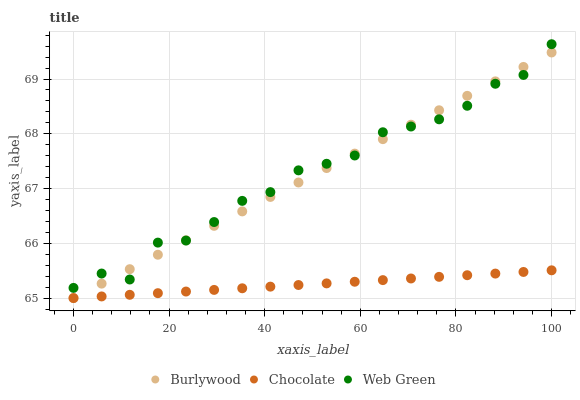Does Chocolate have the minimum area under the curve?
Answer yes or no. Yes. Does Web Green have the maximum area under the curve?
Answer yes or no. Yes. Does Web Green have the minimum area under the curve?
Answer yes or no. No. Does Chocolate have the maximum area under the curve?
Answer yes or no. No. Is Chocolate the smoothest?
Answer yes or no. Yes. Is Web Green the roughest?
Answer yes or no. Yes. Is Web Green the smoothest?
Answer yes or no. No. Is Chocolate the roughest?
Answer yes or no. No. Does Burlywood have the lowest value?
Answer yes or no. Yes. Does Web Green have the lowest value?
Answer yes or no. No. Does Web Green have the highest value?
Answer yes or no. Yes. Does Chocolate have the highest value?
Answer yes or no. No. Is Chocolate less than Web Green?
Answer yes or no. Yes. Is Web Green greater than Chocolate?
Answer yes or no. Yes. Does Web Green intersect Burlywood?
Answer yes or no. Yes. Is Web Green less than Burlywood?
Answer yes or no. No. Is Web Green greater than Burlywood?
Answer yes or no. No. Does Chocolate intersect Web Green?
Answer yes or no. No. 